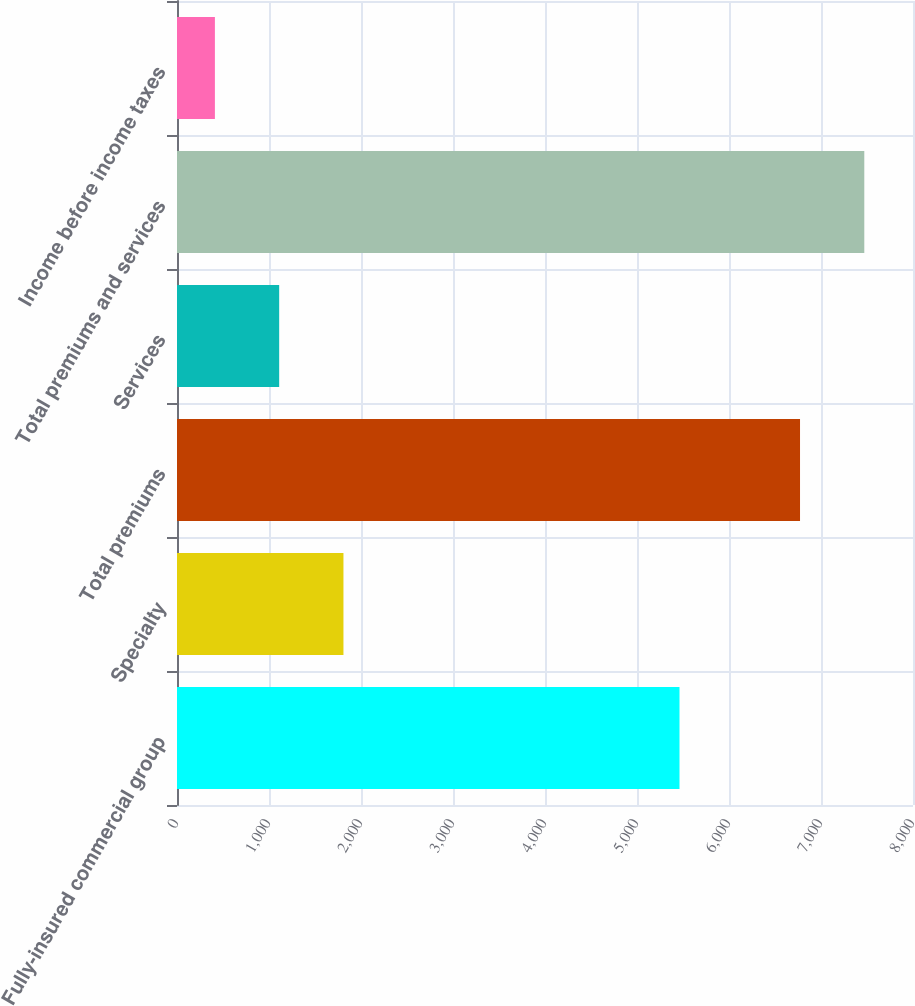Convert chart. <chart><loc_0><loc_0><loc_500><loc_500><bar_chart><fcel>Fully-insured commercial group<fcel>Specialty<fcel>Total premiums<fcel>Services<fcel>Total premiums and services<fcel>Income before income taxes<nl><fcel>5462<fcel>1809.2<fcel>6772<fcel>1110.6<fcel>7470.6<fcel>412<nl></chart> 